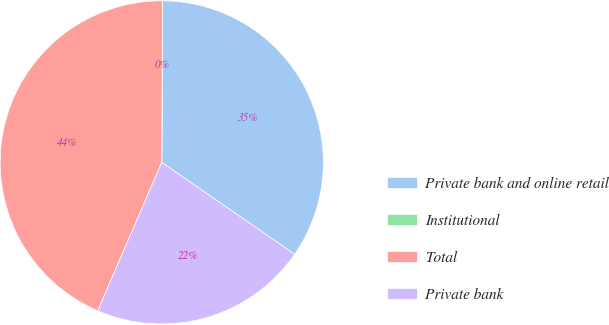Convert chart to OTSL. <chart><loc_0><loc_0><loc_500><loc_500><pie_chart><fcel>Private bank and online retail<fcel>Institutional<fcel>Total<fcel>Private bank<nl><fcel>34.54%<fcel>0.01%<fcel>43.59%<fcel>21.86%<nl></chart> 